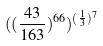<formula> <loc_0><loc_0><loc_500><loc_500>( ( \frac { 4 3 } { 1 6 3 } ) ^ { 6 6 } ) ^ { ( \frac { 1 } { 3 } ) ^ { 7 } }</formula> 